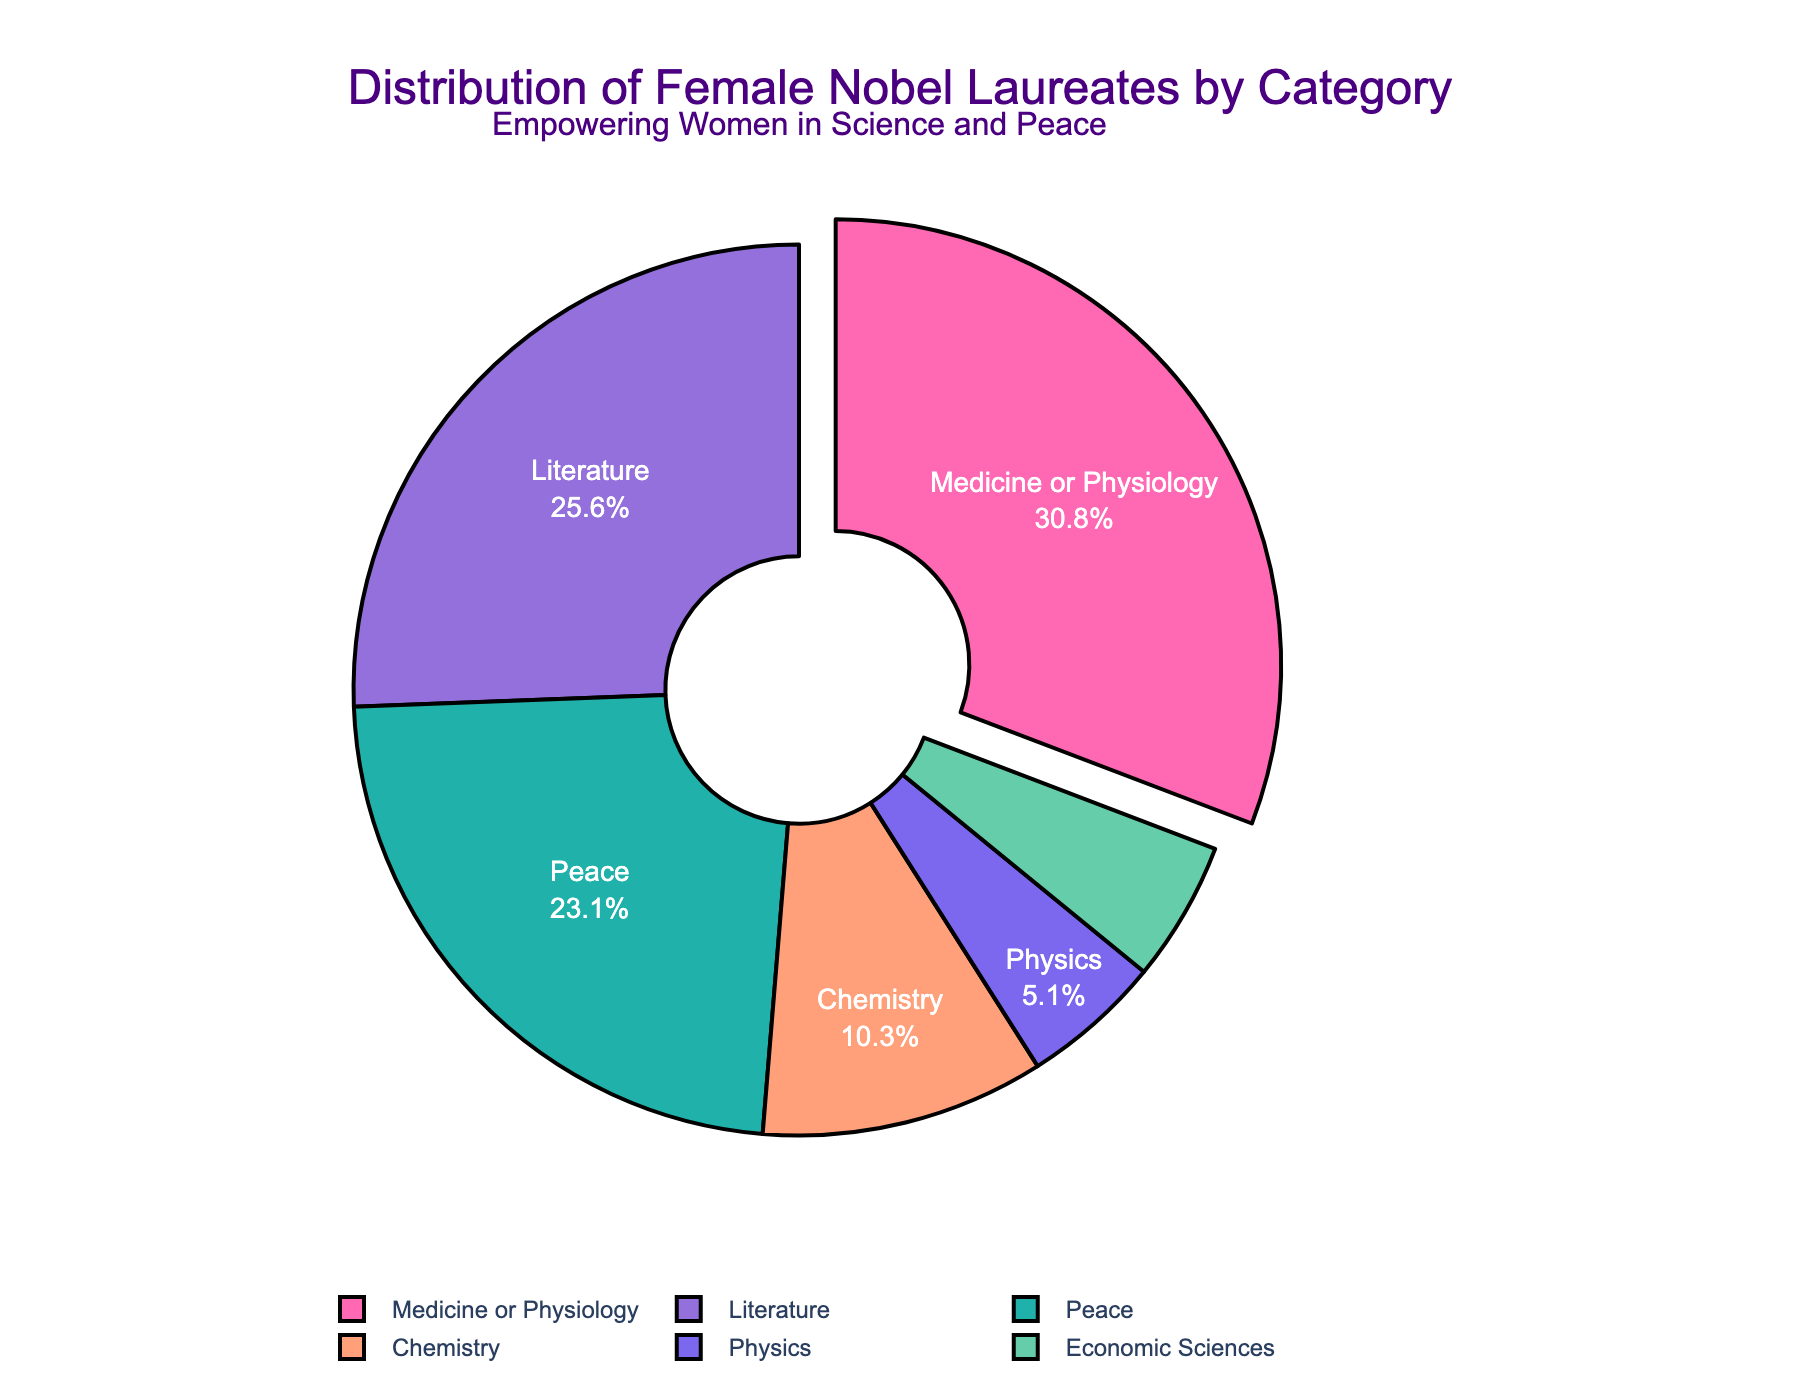Which category has the highest percentage of female Nobel laureates? The figure clearly shows that Medicine or Physiology has the largest segment in the pie chart, indicating the highest percentage.
Answer: Medicine or Physiology Which two categories have equal percentages of female Nobel laureates? By examining the pie chart, it can be seen that Physics and Economic Sciences have segments of the same size, indicating equal percentages.
Answer: Physics and Economic Sciences What is the combined percentage of female Nobel laureates in Peace and Literature? Adding the percentages from the Peace segment (23.1%) and Literature segment (25.6%) results in 23.1 + 25.6 = 48.7%.
Answer: 48.7% How much greater is the percentage of female laureates in Medicine or Physiology compared to Chemistry? The figure shows Medicine or Physiology at 30.8% and Chemistry at 10.3%. Subtracting these gives 30.8 - 10.3 = 20.5%.
Answer: 20.5% Which category has the smallest percentage of female Nobel laureates? The smallest segment in the pie chart belongs to both Physics and Economic Sciences, each with 5.1%.
Answer: Physics and Economic Sciences What is the difference in percentage between the category with the highest and the category with the lowest female Nobel laureates? The highest percentage is 30.8% (Medicine or Physiology) and the lowest is 5.1% (Physics and Economic Sciences). The difference is 30.8 - 5.1 = 25.7%.
Answer: 25.7% Which category is represented by the second largest segment in the pie chart? The second largest segment is represented by Literature, visually evident in the pie chart.
Answer: Literature What is the total percentage of female Nobel laureates in categories related to science (Medicine or Physiology, Chemistry, and Physics)? The sum of the percentages in Medicine or Physiology (30.8%), Chemistry (10.3%), and Physics (5.1%) results in 30.8 + 10.3 + 5.1 = 46.2%.
Answer: 46.2% If we group non-science categories (Literature, Peace, Economic Sciences), what percentage do they represent together? Adding the percentages of Literature (25.6%), Peace (23.1%), and Economic Sciences (5.1%) results in 25.6 + 23.1 + 5.1 = 53.8%.
Answer: 53.8% What is the difference in percentage between Peace and Chemistry categories? The Peace category is 23.1% and the Chemistry category is 10.3%. The difference is 23.1 - 10.3 = 12.8%.
Answer: 12.8% 